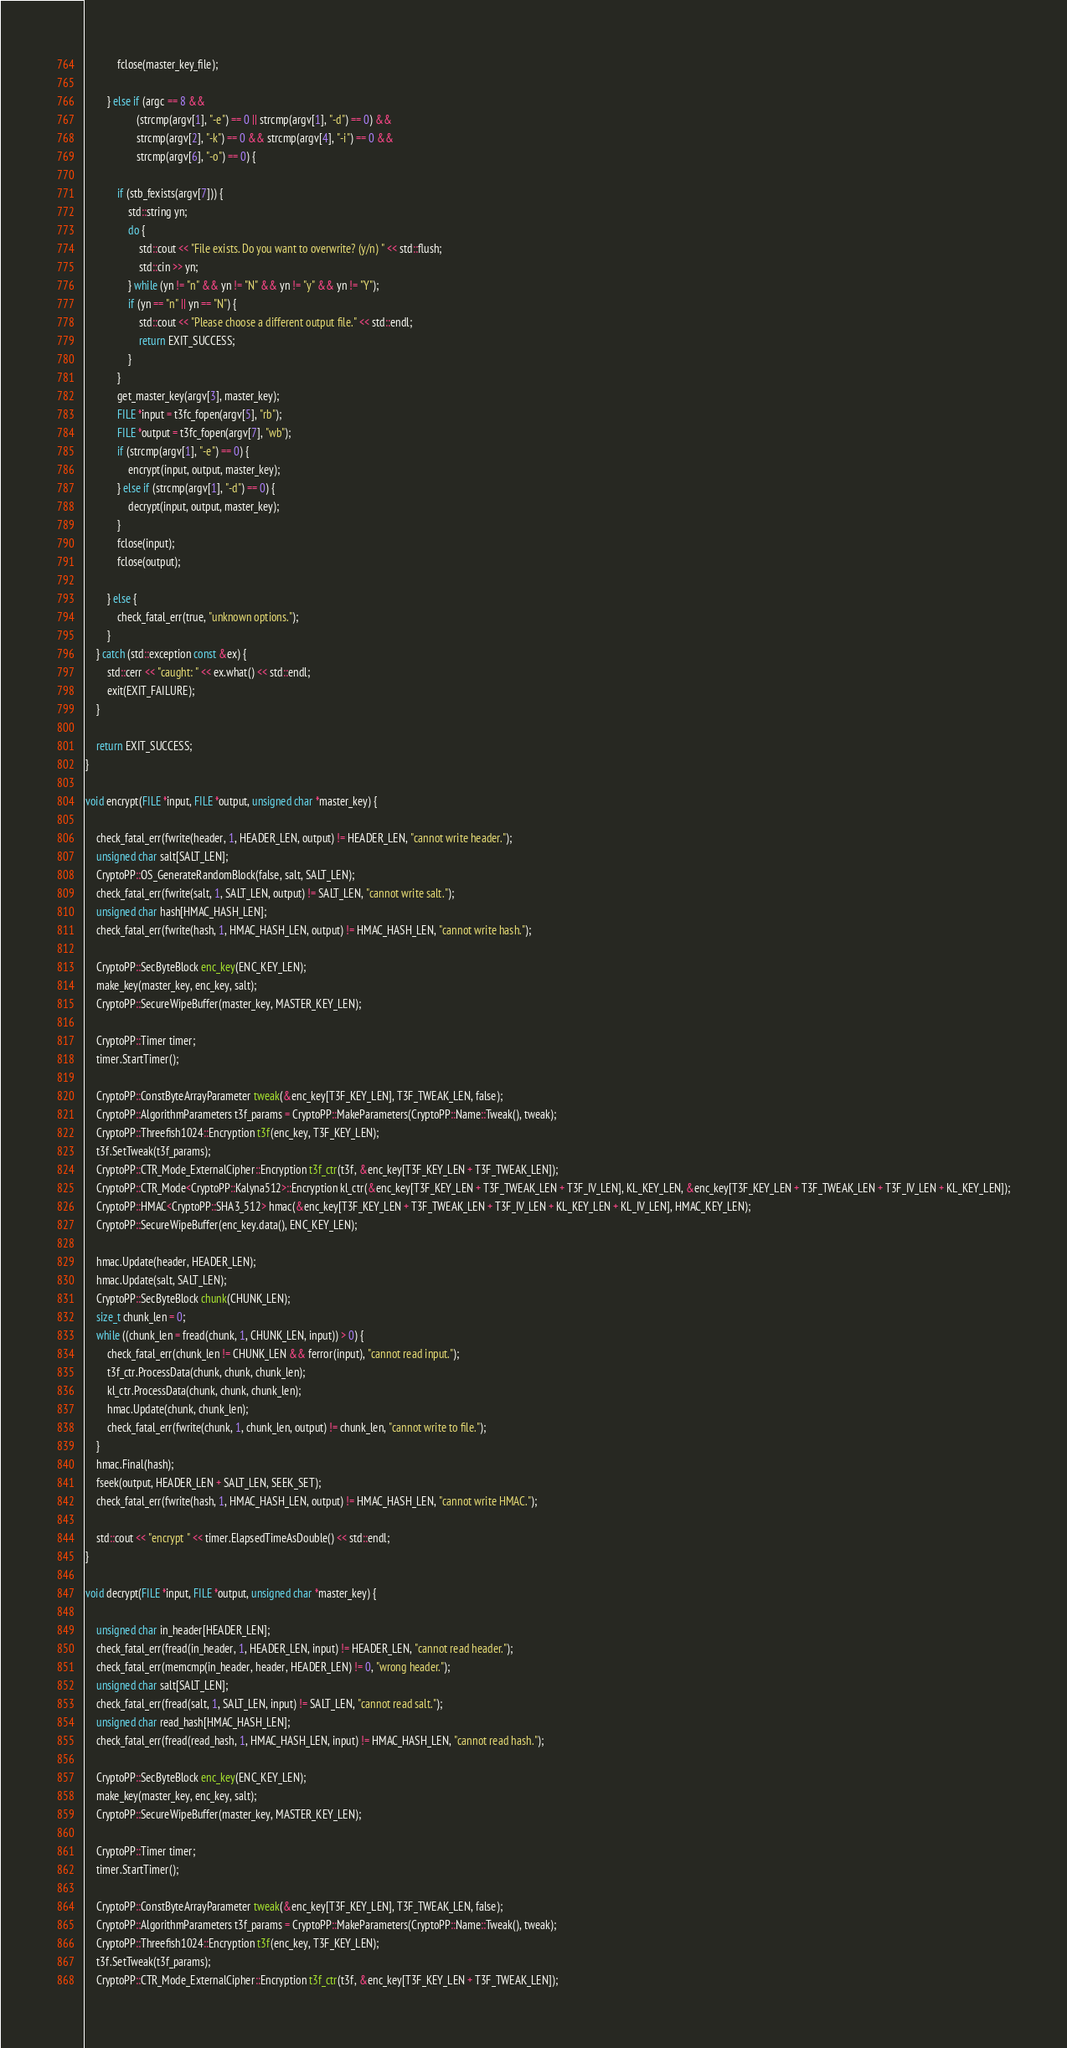<code> <loc_0><loc_0><loc_500><loc_500><_C++_>            fclose(master_key_file);

        } else if (argc == 8 &&
                   (strcmp(argv[1], "-e") == 0 || strcmp(argv[1], "-d") == 0) &&
                   strcmp(argv[2], "-k") == 0 && strcmp(argv[4], "-i") == 0 &&
                   strcmp(argv[6], "-o") == 0) {

            if (stb_fexists(argv[7])) {
                std::string yn;
                do {
                    std::cout << "File exists. Do you want to overwrite? (y/n) " << std::flush;
                    std::cin >> yn;
                } while (yn != "n" && yn != "N" && yn != "y" && yn != "Y");
                if (yn == "n" || yn == "N") {
                    std::cout << "Please choose a different output file." << std::endl;
                    return EXIT_SUCCESS;
                }
            }
            get_master_key(argv[3], master_key);
            FILE *input = t3fc_fopen(argv[5], "rb");
            FILE *output = t3fc_fopen(argv[7], "wb");
            if (strcmp(argv[1], "-e") == 0) {
                encrypt(input, output, master_key);
            } else if (strcmp(argv[1], "-d") == 0) {
                decrypt(input, output, master_key);
            }
            fclose(input);
            fclose(output);

        } else {
            check_fatal_err(true, "unknown options.");
        }
    } catch (std::exception const &ex) {
        std::cerr << "caught: " << ex.what() << std::endl;
        exit(EXIT_FAILURE);
    }

    return EXIT_SUCCESS;
}

void encrypt(FILE *input, FILE *output, unsigned char *master_key) {

    check_fatal_err(fwrite(header, 1, HEADER_LEN, output) != HEADER_LEN, "cannot write header.");
    unsigned char salt[SALT_LEN];
    CryptoPP::OS_GenerateRandomBlock(false, salt, SALT_LEN);
    check_fatal_err(fwrite(salt, 1, SALT_LEN, output) != SALT_LEN, "cannot write salt.");
    unsigned char hash[HMAC_HASH_LEN];
    check_fatal_err(fwrite(hash, 1, HMAC_HASH_LEN, output) != HMAC_HASH_LEN, "cannot write hash.");

    CryptoPP::SecByteBlock enc_key(ENC_KEY_LEN);
    make_key(master_key, enc_key, salt);
    CryptoPP::SecureWipeBuffer(master_key, MASTER_KEY_LEN);

    CryptoPP::Timer timer;
    timer.StartTimer();
    
    CryptoPP::ConstByteArrayParameter tweak(&enc_key[T3F_KEY_LEN], T3F_TWEAK_LEN, false);
    CryptoPP::AlgorithmParameters t3f_params = CryptoPP::MakeParameters(CryptoPP::Name::Tweak(), tweak);
    CryptoPP::Threefish1024::Encryption t3f(enc_key, T3F_KEY_LEN);
    t3f.SetTweak(t3f_params);
    CryptoPP::CTR_Mode_ExternalCipher::Encryption t3f_ctr(t3f, &enc_key[T3F_KEY_LEN + T3F_TWEAK_LEN]);
    CryptoPP::CTR_Mode<CryptoPP::Kalyna512>::Encryption kl_ctr(&enc_key[T3F_KEY_LEN + T3F_TWEAK_LEN + T3F_IV_LEN], KL_KEY_LEN, &enc_key[T3F_KEY_LEN + T3F_TWEAK_LEN + T3F_IV_LEN + KL_KEY_LEN]);
    CryptoPP::HMAC<CryptoPP::SHA3_512> hmac(&enc_key[T3F_KEY_LEN + T3F_TWEAK_LEN + T3F_IV_LEN + KL_KEY_LEN + KL_IV_LEN], HMAC_KEY_LEN);
    CryptoPP::SecureWipeBuffer(enc_key.data(), ENC_KEY_LEN);
    
    hmac.Update(header, HEADER_LEN);
    hmac.Update(salt, SALT_LEN);
    CryptoPP::SecByteBlock chunk(CHUNK_LEN);
    size_t chunk_len = 0;
    while ((chunk_len = fread(chunk, 1, CHUNK_LEN, input)) > 0) {
        check_fatal_err(chunk_len != CHUNK_LEN && ferror(input), "cannot read input.");
        t3f_ctr.ProcessData(chunk, chunk, chunk_len);
        kl_ctr.ProcessData(chunk, chunk, chunk_len);
        hmac.Update(chunk, chunk_len);
        check_fatal_err(fwrite(chunk, 1, chunk_len, output) != chunk_len, "cannot write to file.");
    }
    hmac.Final(hash);
    fseek(output, HEADER_LEN + SALT_LEN, SEEK_SET);
    check_fatal_err(fwrite(hash, 1, HMAC_HASH_LEN, output) != HMAC_HASH_LEN, "cannot write HMAC.");
    
    std::cout << "encrypt " << timer.ElapsedTimeAsDouble() << std::endl;
}

void decrypt(FILE *input, FILE *output, unsigned char *master_key) {
    
    unsigned char in_header[HEADER_LEN];
    check_fatal_err(fread(in_header, 1, HEADER_LEN, input) != HEADER_LEN, "cannot read header.");
    check_fatal_err(memcmp(in_header, header, HEADER_LEN) != 0, "wrong header.");
    unsigned char salt[SALT_LEN];
    check_fatal_err(fread(salt, 1, SALT_LEN, input) != SALT_LEN, "cannot read salt.");
    unsigned char read_hash[HMAC_HASH_LEN];
    check_fatal_err(fread(read_hash, 1, HMAC_HASH_LEN, input) != HMAC_HASH_LEN, "cannot read hash.");
                    
    CryptoPP::SecByteBlock enc_key(ENC_KEY_LEN);
    make_key(master_key, enc_key, salt);
    CryptoPP::SecureWipeBuffer(master_key, MASTER_KEY_LEN);
    
    CryptoPP::Timer timer;
    timer.StartTimer();
    
    CryptoPP::ConstByteArrayParameter tweak(&enc_key[T3F_KEY_LEN], T3F_TWEAK_LEN, false);
    CryptoPP::AlgorithmParameters t3f_params = CryptoPP::MakeParameters(CryptoPP::Name::Tweak(), tweak);
    CryptoPP::Threefish1024::Encryption t3f(enc_key, T3F_KEY_LEN);
    t3f.SetTweak(t3f_params);
    CryptoPP::CTR_Mode_ExternalCipher::Encryption t3f_ctr(t3f, &enc_key[T3F_KEY_LEN + T3F_TWEAK_LEN]);</code> 